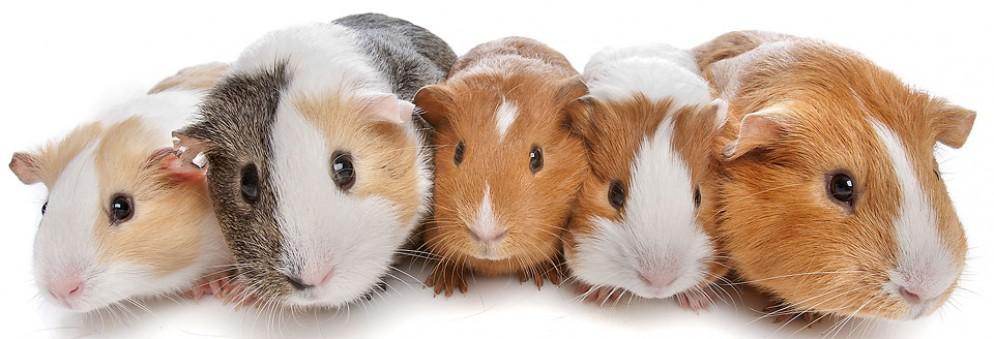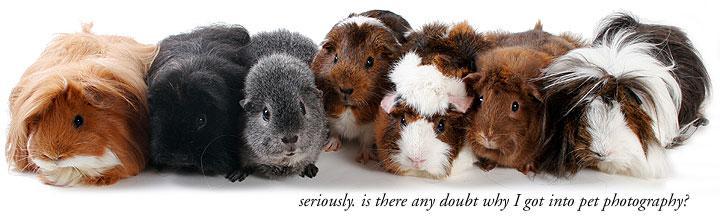The first image is the image on the left, the second image is the image on the right. Assess this claim about the two images: "Several guinea pigs are eating hay.". Correct or not? Answer yes or no. No. The first image is the image on the left, the second image is the image on the right. Assess this claim about the two images: "Neither individual image includes more than seven guinea pigs.". Correct or not? Answer yes or no. Yes. 